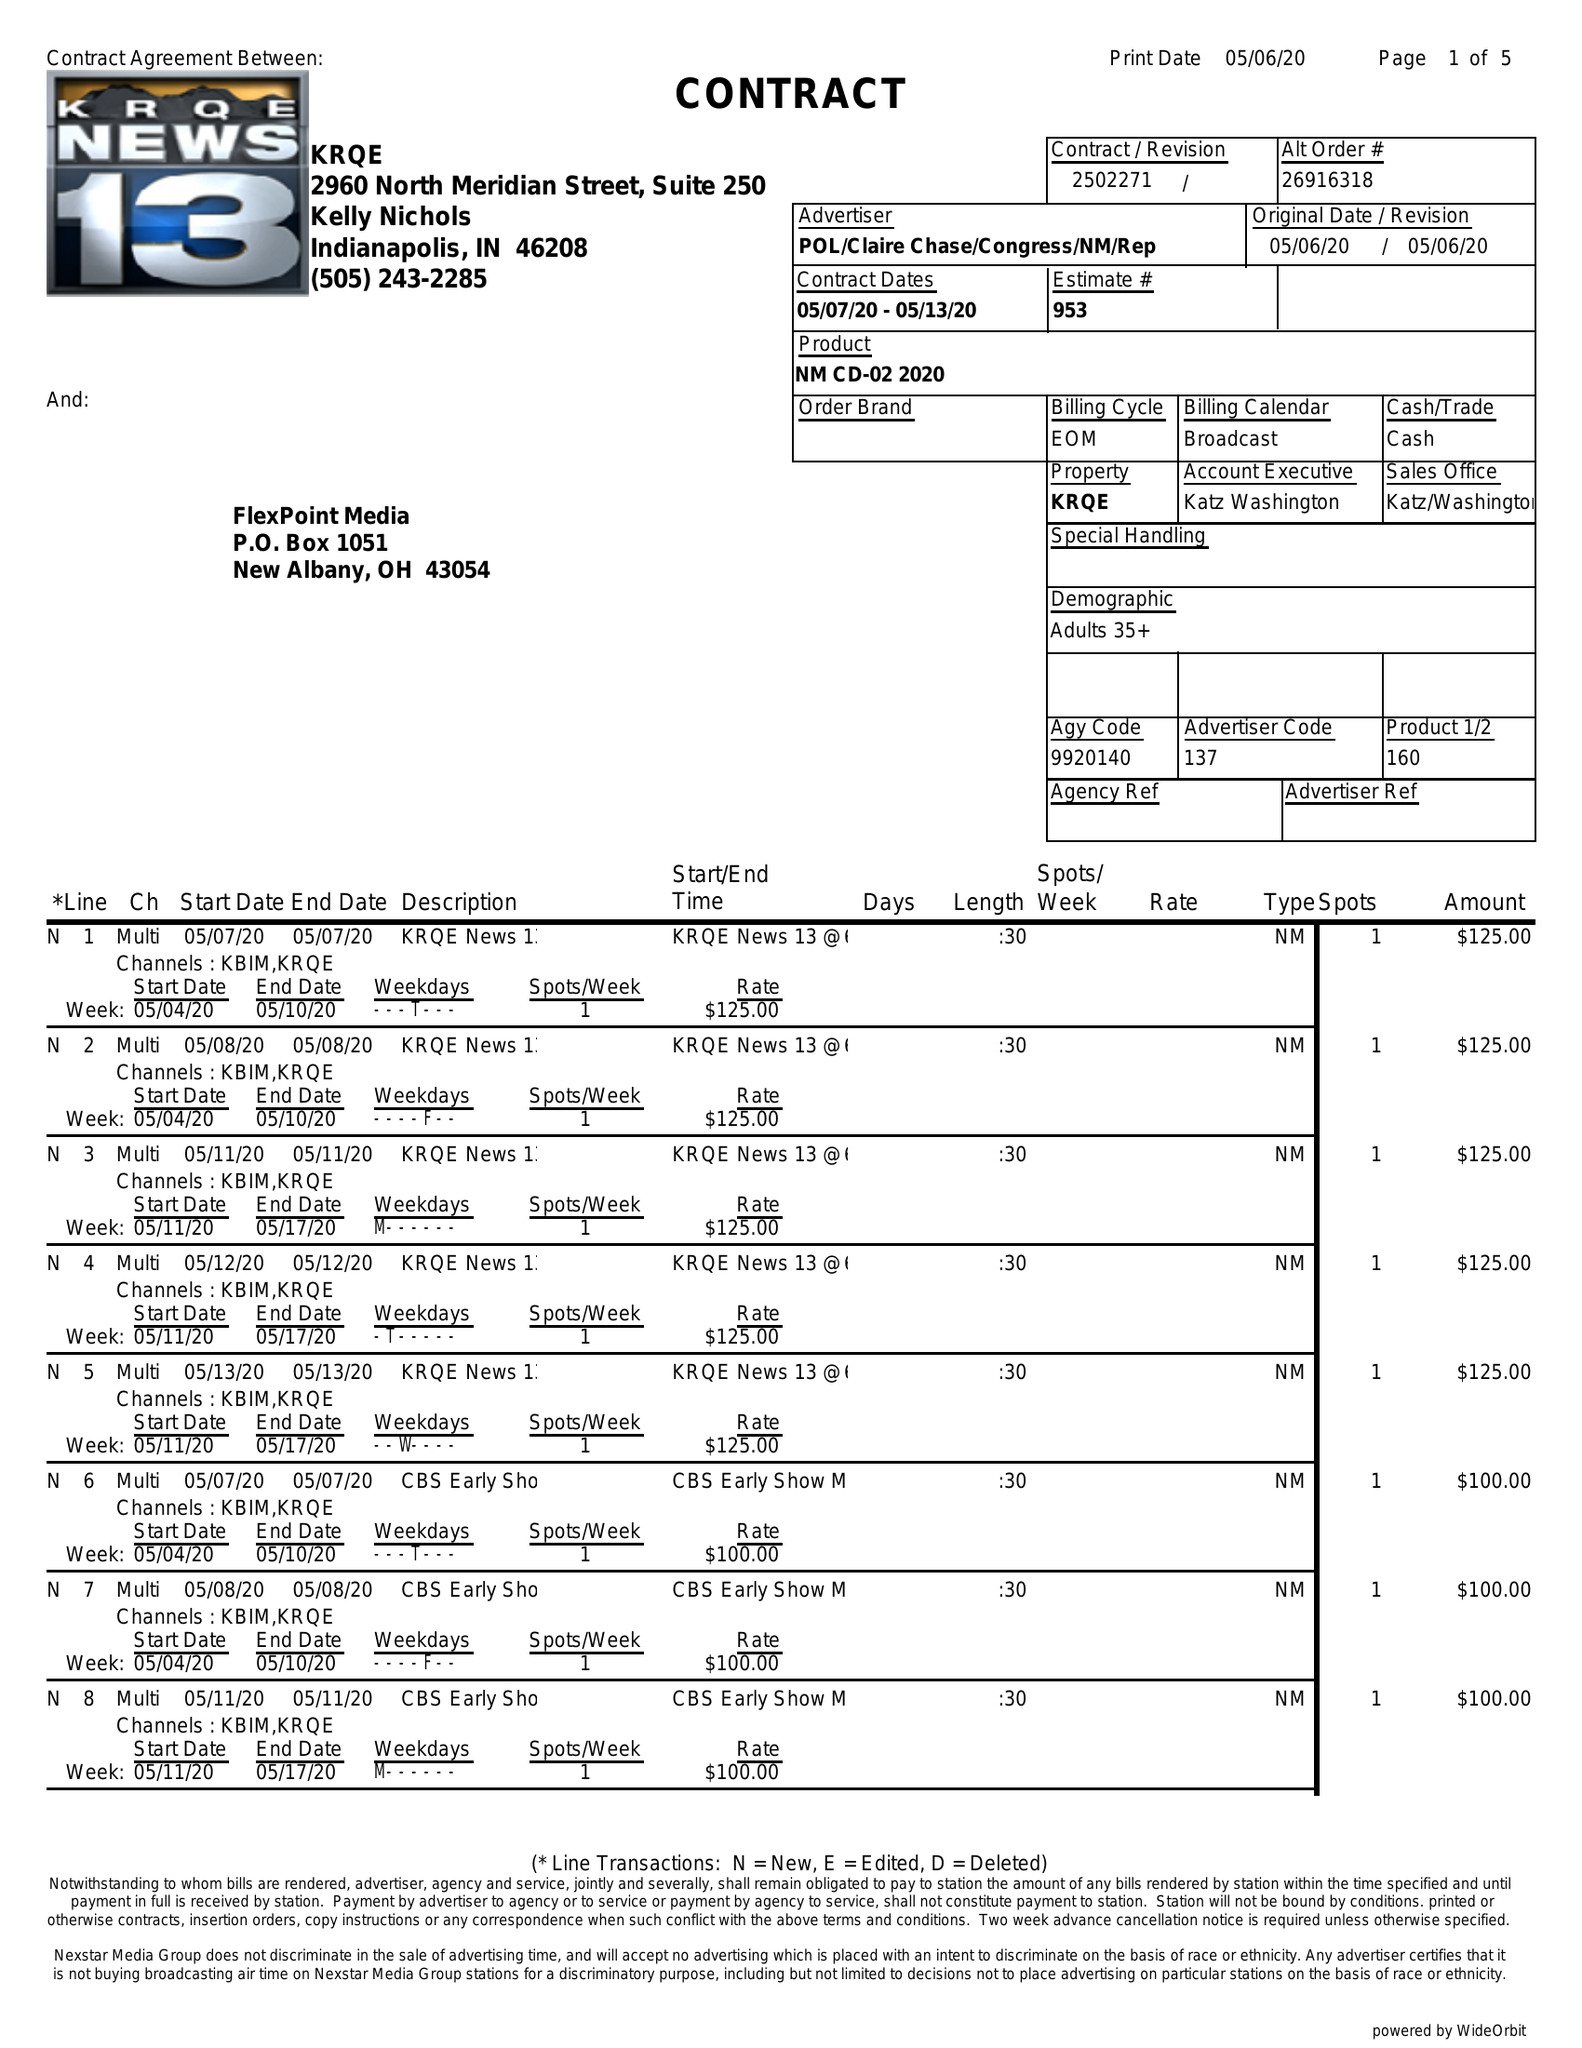What is the value for the advertiser?
Answer the question using a single word or phrase. POL/CLAIRECHASE/CONGRESS/NM/REP 